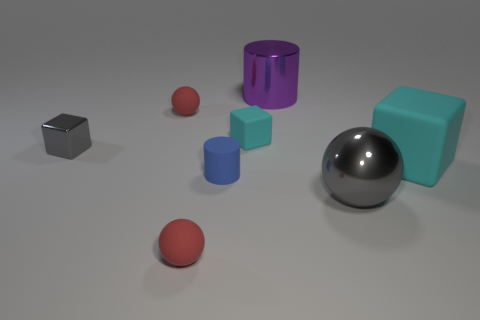Does the tiny metal thing have the same shape as the red matte object in front of the large matte thing? no 